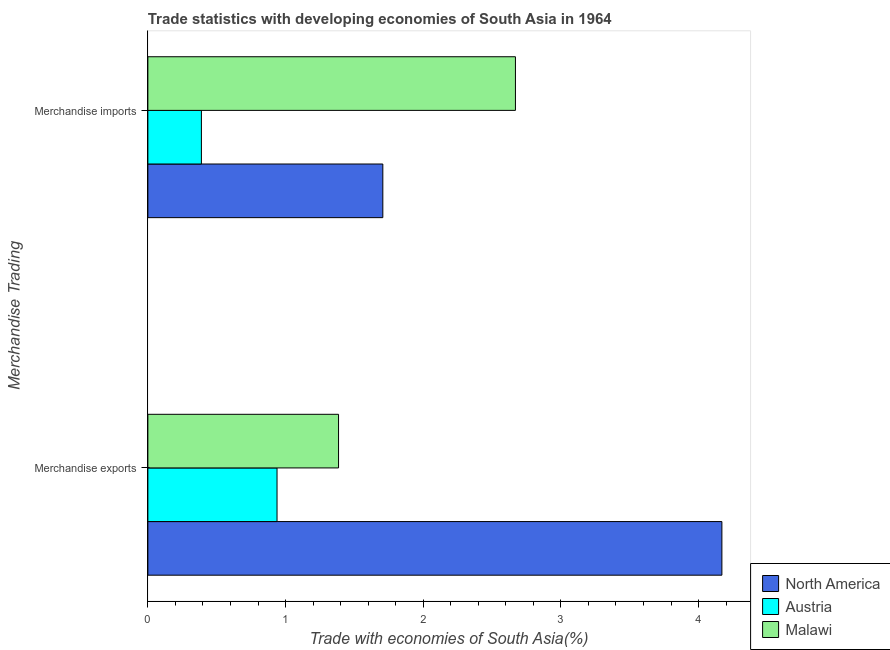Are the number of bars per tick equal to the number of legend labels?
Provide a short and direct response. Yes. How many bars are there on the 1st tick from the top?
Offer a very short reply. 3. How many bars are there on the 2nd tick from the bottom?
Provide a succinct answer. 3. What is the merchandise exports in Malawi?
Offer a terse response. 1.39. Across all countries, what is the maximum merchandise exports?
Offer a very short reply. 4.17. Across all countries, what is the minimum merchandise exports?
Provide a succinct answer. 0.94. What is the total merchandise imports in the graph?
Offer a very short reply. 4.77. What is the difference between the merchandise exports in Malawi and that in Austria?
Provide a short and direct response. 0.45. What is the difference between the merchandise imports in Austria and the merchandise exports in Malawi?
Provide a short and direct response. -1. What is the average merchandise imports per country?
Make the answer very short. 1.59. What is the difference between the merchandise exports and merchandise imports in Austria?
Keep it short and to the point. 0.55. In how many countries, is the merchandise exports greater than 1.6 %?
Keep it short and to the point. 1. What is the ratio of the merchandise exports in Malawi to that in Austria?
Ensure brevity in your answer.  1.48. In how many countries, is the merchandise exports greater than the average merchandise exports taken over all countries?
Give a very brief answer. 1. What does the 3rd bar from the top in Merchandise imports represents?
Provide a succinct answer. North America. What does the 2nd bar from the bottom in Merchandise imports represents?
Offer a terse response. Austria. How many bars are there?
Keep it short and to the point. 6. How are the legend labels stacked?
Provide a succinct answer. Vertical. What is the title of the graph?
Your answer should be very brief. Trade statistics with developing economies of South Asia in 1964. What is the label or title of the X-axis?
Ensure brevity in your answer.  Trade with economies of South Asia(%). What is the label or title of the Y-axis?
Provide a succinct answer. Merchandise Trading. What is the Trade with economies of South Asia(%) in North America in Merchandise exports?
Your answer should be very brief. 4.17. What is the Trade with economies of South Asia(%) of Austria in Merchandise exports?
Offer a terse response. 0.94. What is the Trade with economies of South Asia(%) in Malawi in Merchandise exports?
Offer a terse response. 1.39. What is the Trade with economies of South Asia(%) in North America in Merchandise imports?
Ensure brevity in your answer.  1.71. What is the Trade with economies of South Asia(%) of Austria in Merchandise imports?
Offer a very short reply. 0.39. What is the Trade with economies of South Asia(%) of Malawi in Merchandise imports?
Make the answer very short. 2.67. Across all Merchandise Trading, what is the maximum Trade with economies of South Asia(%) in North America?
Your response must be concise. 4.17. Across all Merchandise Trading, what is the maximum Trade with economies of South Asia(%) in Austria?
Ensure brevity in your answer.  0.94. Across all Merchandise Trading, what is the maximum Trade with economies of South Asia(%) in Malawi?
Offer a terse response. 2.67. Across all Merchandise Trading, what is the minimum Trade with economies of South Asia(%) of North America?
Your answer should be very brief. 1.71. Across all Merchandise Trading, what is the minimum Trade with economies of South Asia(%) of Austria?
Ensure brevity in your answer.  0.39. Across all Merchandise Trading, what is the minimum Trade with economies of South Asia(%) of Malawi?
Keep it short and to the point. 1.39. What is the total Trade with economies of South Asia(%) of North America in the graph?
Your response must be concise. 5.88. What is the total Trade with economies of South Asia(%) of Austria in the graph?
Your response must be concise. 1.33. What is the total Trade with economies of South Asia(%) in Malawi in the graph?
Ensure brevity in your answer.  4.05. What is the difference between the Trade with economies of South Asia(%) of North America in Merchandise exports and that in Merchandise imports?
Your answer should be compact. 2.46. What is the difference between the Trade with economies of South Asia(%) of Austria in Merchandise exports and that in Merchandise imports?
Ensure brevity in your answer.  0.55. What is the difference between the Trade with economies of South Asia(%) of Malawi in Merchandise exports and that in Merchandise imports?
Keep it short and to the point. -1.28. What is the difference between the Trade with economies of South Asia(%) in North America in Merchandise exports and the Trade with economies of South Asia(%) in Austria in Merchandise imports?
Make the answer very short. 3.78. What is the difference between the Trade with economies of South Asia(%) in North America in Merchandise exports and the Trade with economies of South Asia(%) in Malawi in Merchandise imports?
Offer a very short reply. 1.5. What is the difference between the Trade with economies of South Asia(%) of Austria in Merchandise exports and the Trade with economies of South Asia(%) of Malawi in Merchandise imports?
Provide a short and direct response. -1.73. What is the average Trade with economies of South Asia(%) in North America per Merchandise Trading?
Give a very brief answer. 2.94. What is the average Trade with economies of South Asia(%) of Austria per Merchandise Trading?
Your answer should be compact. 0.66. What is the average Trade with economies of South Asia(%) in Malawi per Merchandise Trading?
Make the answer very short. 2.03. What is the difference between the Trade with economies of South Asia(%) of North America and Trade with economies of South Asia(%) of Austria in Merchandise exports?
Your answer should be very brief. 3.23. What is the difference between the Trade with economies of South Asia(%) of North America and Trade with economies of South Asia(%) of Malawi in Merchandise exports?
Keep it short and to the point. 2.78. What is the difference between the Trade with economies of South Asia(%) in Austria and Trade with economies of South Asia(%) in Malawi in Merchandise exports?
Your answer should be very brief. -0.45. What is the difference between the Trade with economies of South Asia(%) in North America and Trade with economies of South Asia(%) in Austria in Merchandise imports?
Provide a short and direct response. 1.32. What is the difference between the Trade with economies of South Asia(%) in North America and Trade with economies of South Asia(%) in Malawi in Merchandise imports?
Your response must be concise. -0.96. What is the difference between the Trade with economies of South Asia(%) in Austria and Trade with economies of South Asia(%) in Malawi in Merchandise imports?
Provide a short and direct response. -2.28. What is the ratio of the Trade with economies of South Asia(%) in North America in Merchandise exports to that in Merchandise imports?
Provide a succinct answer. 2.44. What is the ratio of the Trade with economies of South Asia(%) in Austria in Merchandise exports to that in Merchandise imports?
Give a very brief answer. 2.41. What is the ratio of the Trade with economies of South Asia(%) of Malawi in Merchandise exports to that in Merchandise imports?
Your answer should be very brief. 0.52. What is the difference between the highest and the second highest Trade with economies of South Asia(%) of North America?
Make the answer very short. 2.46. What is the difference between the highest and the second highest Trade with economies of South Asia(%) in Austria?
Keep it short and to the point. 0.55. What is the difference between the highest and the second highest Trade with economies of South Asia(%) of Malawi?
Ensure brevity in your answer.  1.28. What is the difference between the highest and the lowest Trade with economies of South Asia(%) in North America?
Provide a succinct answer. 2.46. What is the difference between the highest and the lowest Trade with economies of South Asia(%) in Austria?
Offer a very short reply. 0.55. What is the difference between the highest and the lowest Trade with economies of South Asia(%) in Malawi?
Give a very brief answer. 1.28. 